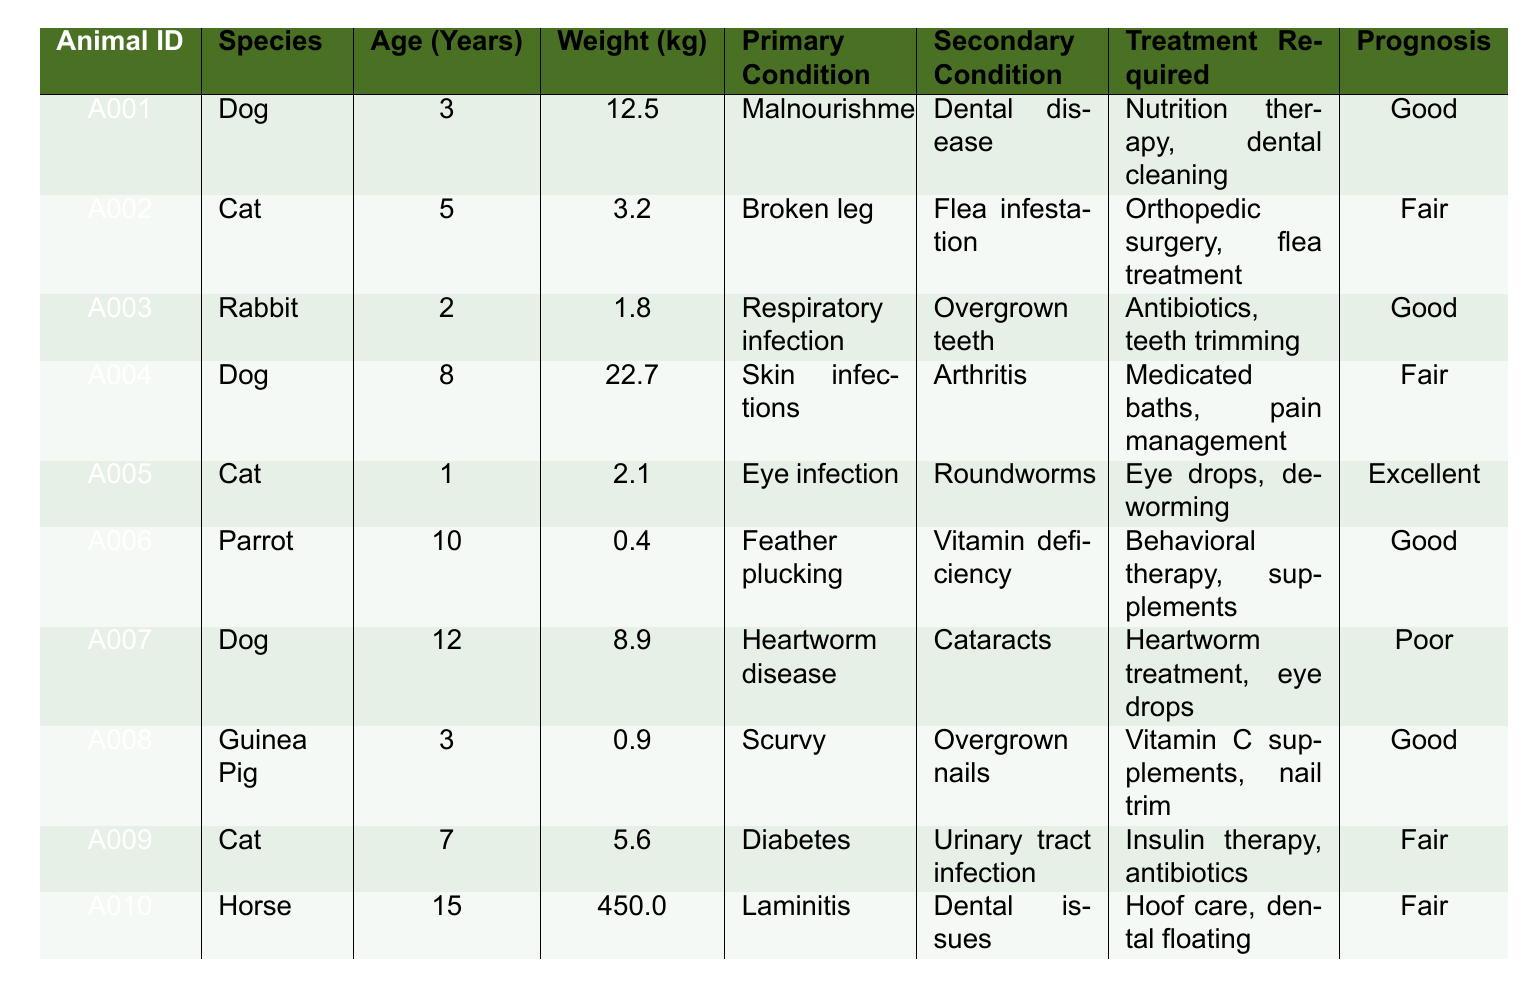What is the primary condition of Animal ID A005? The table shows that Animal ID A005 is a Cat, and its primary condition is listed as "Eye infection."
Answer: Eye infection How many animals have a prognosis classified as "Poor"? By reviewing the prognosis column, only one animal (Animal ID A007) has a prognosis of "Poor."
Answer: 1 What is the average age of the animals in the table? The ages of the animals listed are 3, 5, 2, 8, 1, 10, 12, 3, 7, and 15. Summing all ages: 3 + 5 + 2 + 8 + 1 + 10 + 12 + 3 + 7 + 15 = 66. There are 10 animals, so the average is 66/10 = 6.6 years.
Answer: 6.6 years Does any animal have a secondary condition of "Dental issues"? Looking through the secondary condition column, there are no animals listed with "Dental issues" as a secondary condition.
Answer: No Which animal requires "Orthopedic surgery"? The animal that requires "Orthopedic surgery" is Animal ID A002, which is a Cat with a primary condition of "Broken leg."
Answer: A002 Which species has the highest average weight? The weights of the animals are as follows: Dog (12.5, 22.7, 8.9), Cat (3.2, 2.1, 5.6), Rabbit (1.8), Parrot (0.4), Guinea Pig (0.9), Horse (450.0). The average weights are: Dog: (12.5 + 22.7 + 8.9) / 3 = 14.7; Cat: (3.2 + 2.1 + 5.6) / 3 = 3.7; Rabbit: 1.8; Parrot: 0.4; Guinea Pig: 0.9; Horse: 450. The Horse has the highest average weight of 450.
Answer: Horse What treatment is required for the animal with a heart condition? The animal with a heart condition is Animal ID A007. The treatment required for this animal is "Heartworm treatment, eye drops."
Answer: Heartworm treatment, eye drops Which animal has the lowest recorded weight? Reviewing the weight column, the lowest recorded weight is for the Parrot (Animal ID A006), which weighs 0.4 kg.
Answer: 0.4 kg Are there more cats than dogs in the table? There are 3 cats (A002, A005, A009) and 3 dogs (A001, A004, A007) in the table. Since they are equal, there are not more cats than dogs.
Answer: No If we consider only the animals with a prognosis of "Good," what is the most common primary condition among them? The animals with a prognosis of "Good" are: A001 (Malnourishment), A003 (Respiratory infection), A006 (Feather plucking), and A008 (Scurvy). The primary conditions are different with no recurring condition among these four, so there is no most common primary condition in this group.
Answer: None What are the treatments required for the animal with a diagnosis of Diabetes? The animal with Diabetes is Animal ID A009, which requires "Insulin therapy, antibiotics."
Answer: Insulin therapy, antibiotics 